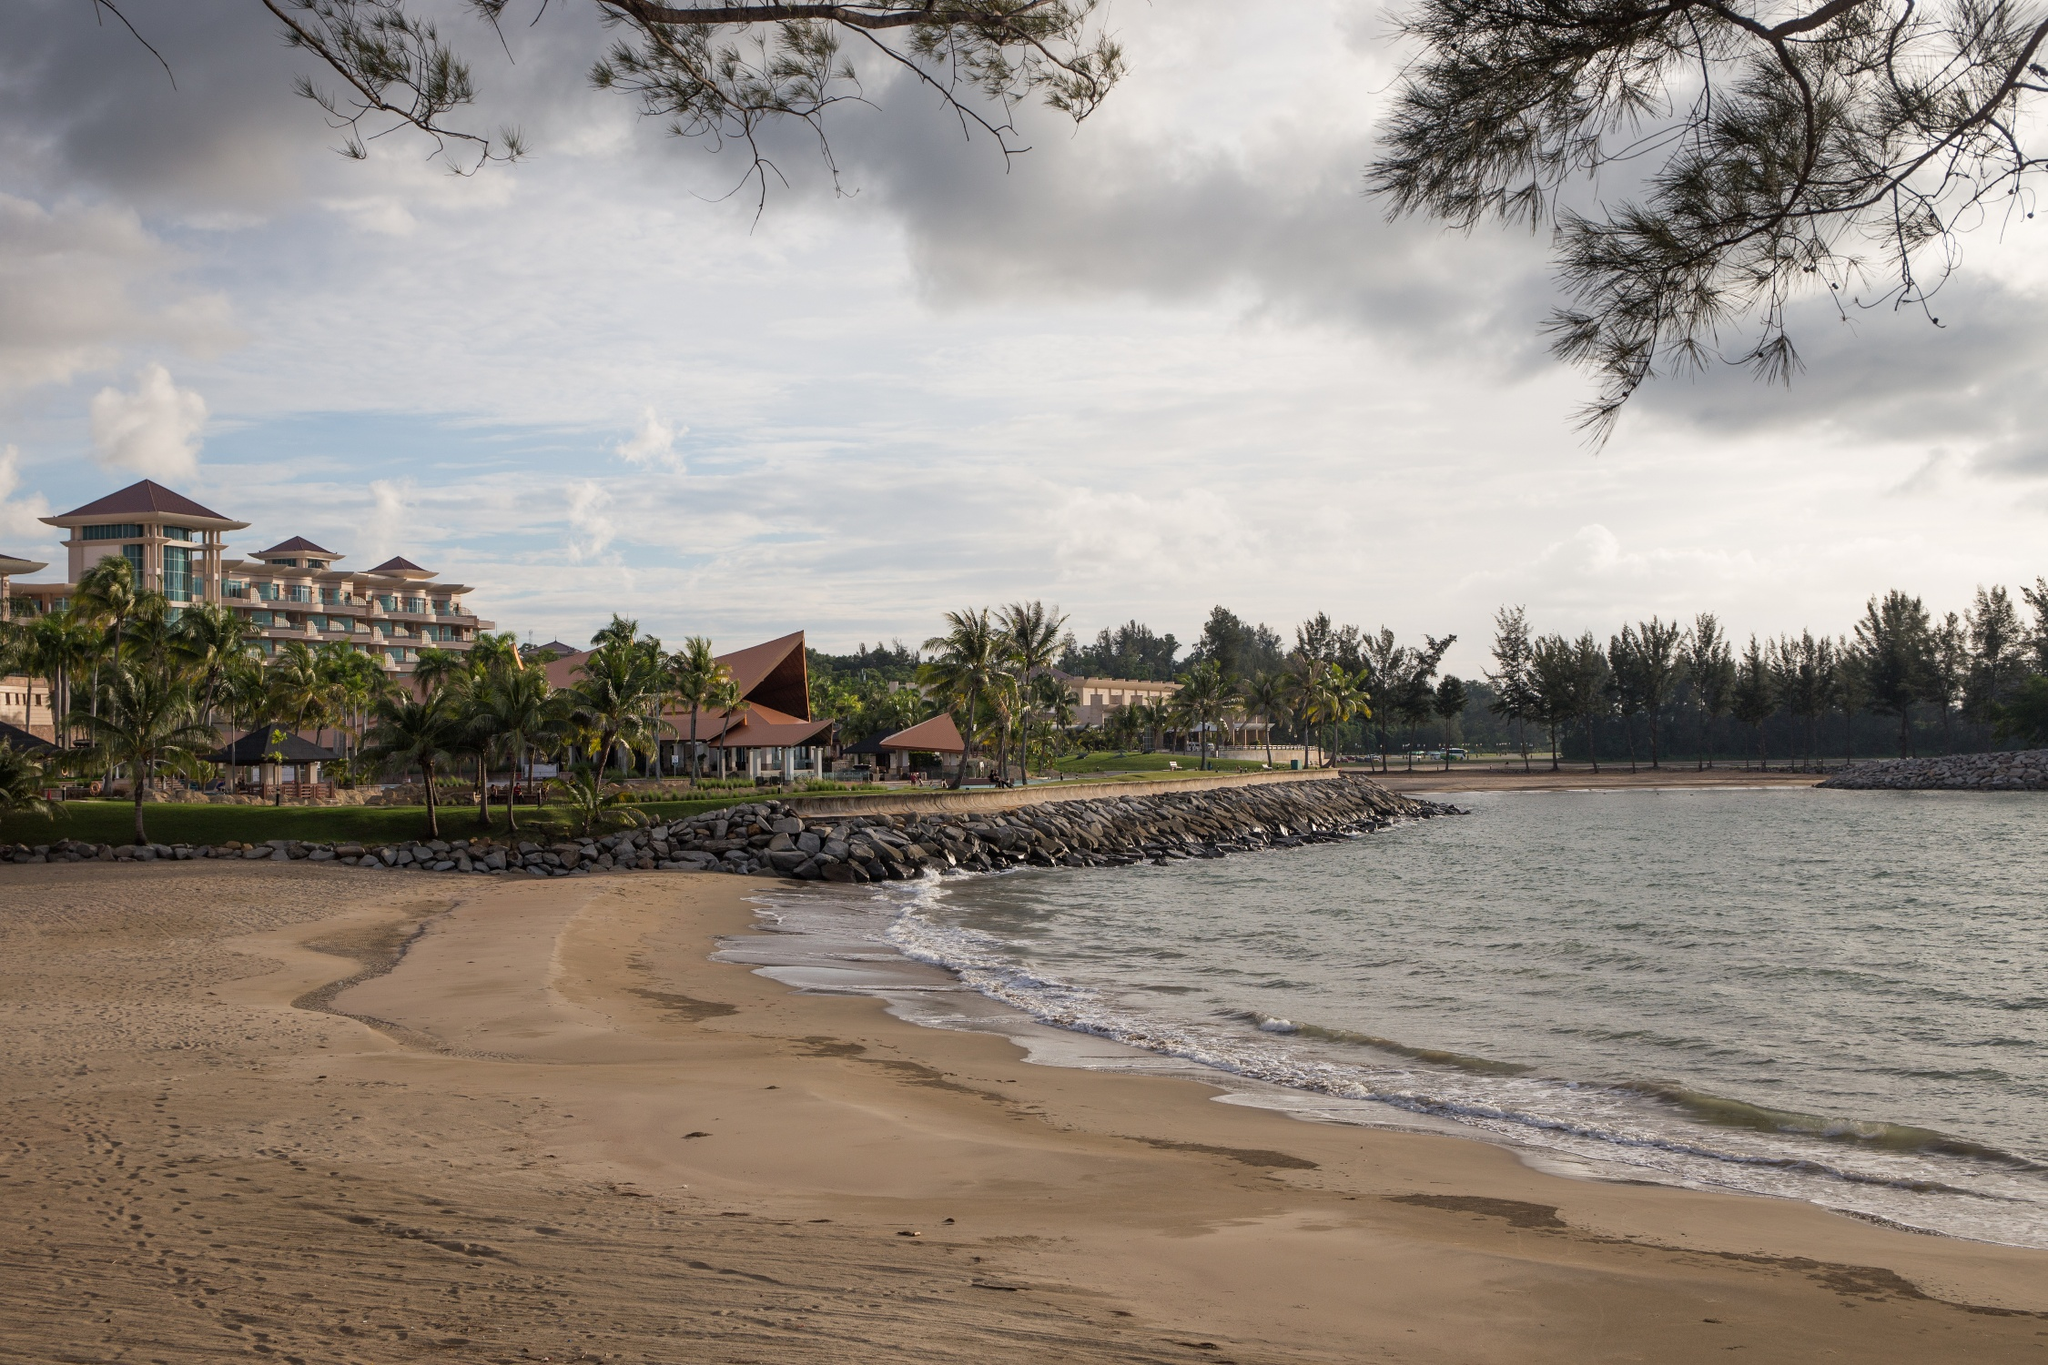What might be a day in the life of a guest staying at this beach resort? A day in the life of a guest at this beach resort begins with waking up to the gentle sound of waves and the sight of a beautiful sunrise over the ocean. After a refreshing morning swim or a yoga session on the beach, guests could indulge in a hearty breakfast featuring local tropical fruits and freshly baked pastries. The day might be filled with various activities such as lounging by the pool, embarking on a kayaking adventure, or exploring the local marine life through snorkeling. Afternoon relaxation could include a spa treatment or a hammock nap under the swaying palm trees. The evening could be reserved for enjoying a scenic beachside dinner while watching the sunset, followed by live entertainment or a cultural performance provided by the resort. This harmonious blend of relaxation, adventure, and cultural immersion ensures every moment is cherished. Can you paint a picture of what the hotel's spa facilities might be like? The spa facilities at this beach resort are likely a sanctuary of relaxation and rejuvenation. Imagine a serene setting where the spa rooms offer panoramic views of the ocean, allowing guests to relax to the sound of gentle waves. The interiors are designed with natural elements such as bamboo, stone, and flowing water features, creating a harmonious and soothing environment. Guests can choose from a variety of treatments, including traditional massages using local oils and herbs, facials, and body scrubs that leave the skin glowing. The spa might also include steam rooms, saunas, and a tranquil indoor pool. Additionally, outdoor treatment areas may be available, allowing guests to enjoy their massage while feeling the ocean breeze and listening to nature's symphony. Luxurious amenities such as plush robes, herbal teas, and soothing music enhance the overall experience, ensuring complete relaxation and well-being. What would it be like to host a major event, like a wedding, at this resort? Hosting a wedding at this beach resort would be nothing short of magical. Picture a beautifully decorated beachfront ceremony with the backdrop of the setting sun, where guests are seated on the sand underneath elegant canopies. The sound of waves acts as a natural soundtrack to the exchange of vows. The reception could be held in an open-air venue with tables adorned with tropical flowers and lanterns, creating a romantic and enchanting atmosphere. The resort's culinary team would prepare a sumptuous feast, featuring a mix of local delicacies and gourmet cuisine, ensuring that every guest's palate is satisfied. After the formalities, the celebration could continue with dancing under the stars, accompanied by live music or a DJ. The resort's staff would attend to every detail, from arranging floral decorations to setting up a photo booth for guests. Accommodations for the wedding party and guests would be luxurious, offering them a memorable stay with breathtaking views and top-notch service. 